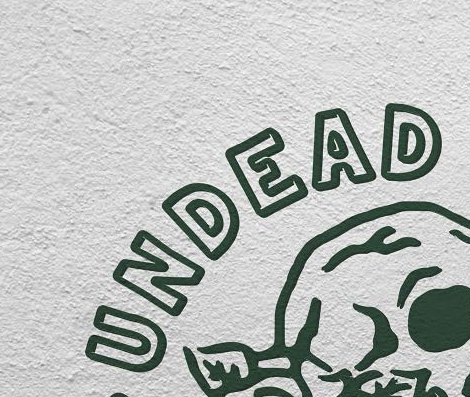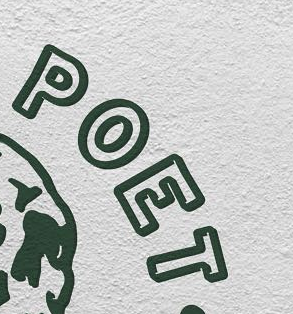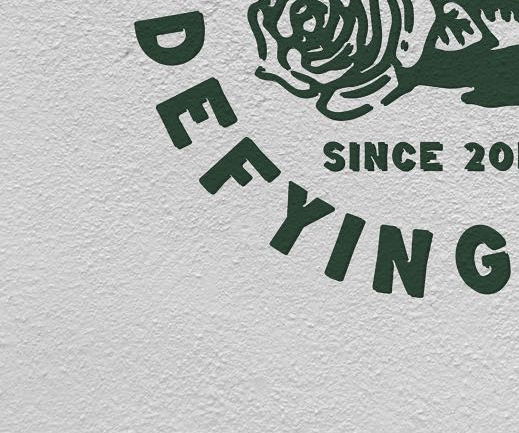Read the text from these images in sequence, separated by a semicolon. UNDEAD; POET; DEFYING 